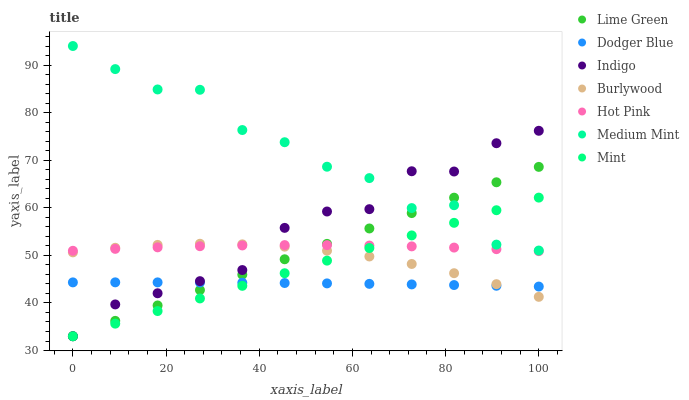Does Dodger Blue have the minimum area under the curve?
Answer yes or no. Yes. Does Medium Mint have the maximum area under the curve?
Answer yes or no. Yes. Does Indigo have the minimum area under the curve?
Answer yes or no. No. Does Indigo have the maximum area under the curve?
Answer yes or no. No. Is Lime Green the smoothest?
Answer yes or no. Yes. Is Medium Mint the roughest?
Answer yes or no. Yes. Is Indigo the smoothest?
Answer yes or no. No. Is Indigo the roughest?
Answer yes or no. No. Does Indigo have the lowest value?
Answer yes or no. Yes. Does Burlywood have the lowest value?
Answer yes or no. No. Does Medium Mint have the highest value?
Answer yes or no. Yes. Does Indigo have the highest value?
Answer yes or no. No. Is Dodger Blue less than Hot Pink?
Answer yes or no. Yes. Is Medium Mint greater than Hot Pink?
Answer yes or no. Yes. Does Medium Mint intersect Mint?
Answer yes or no. Yes. Is Medium Mint less than Mint?
Answer yes or no. No. Is Medium Mint greater than Mint?
Answer yes or no. No. Does Dodger Blue intersect Hot Pink?
Answer yes or no. No. 